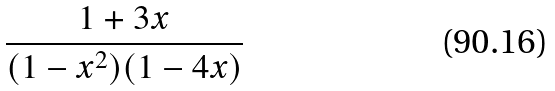Convert formula to latex. <formula><loc_0><loc_0><loc_500><loc_500>\frac { 1 + 3 x } { ( 1 - x ^ { 2 } ) ( 1 - 4 x ) }</formula> 